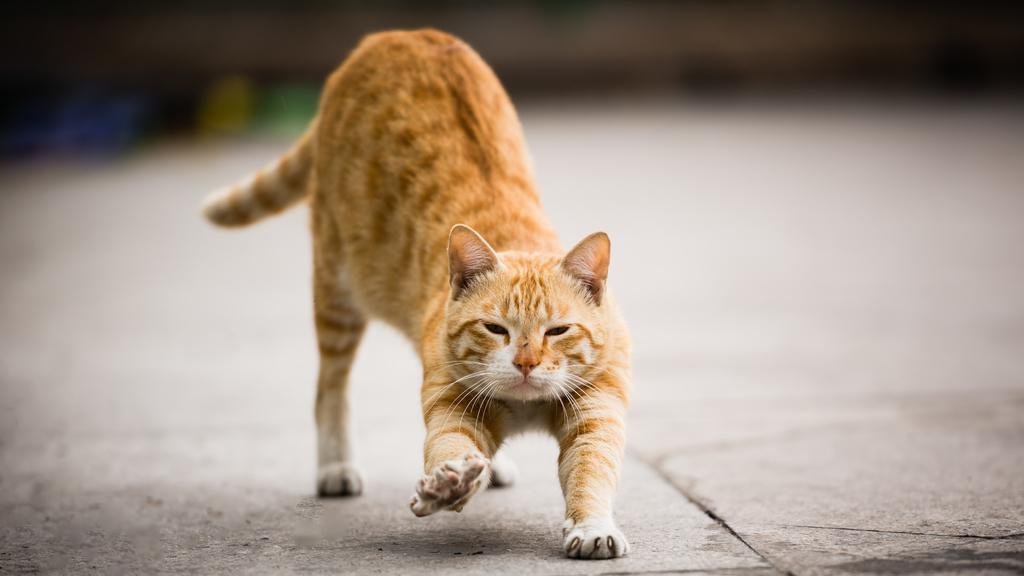What type of animal is present in the image? There is a cat in the image. What is the cat doing in the image? The cat is stretching its legs. Can you describe the background of the image? The backdrop of the image is blurred. How many cherries can be seen on the cat's tail in the image? There are no cherries present in the image, and therefore none can be seen on the cat's tail. What type of emotion does the cat appear to be experiencing in the image? The provided facts do not mention any specific emotion the cat might be experiencing. 